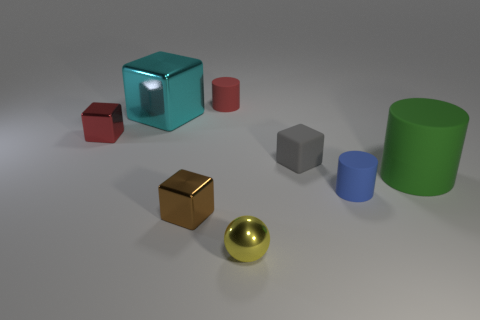What is the material of the red object that is the same shape as the small blue object?
Offer a very short reply. Rubber. There is a metallic cube in front of the tiny gray matte thing that is behind the brown shiny object; how big is it?
Make the answer very short. Small. The big metallic block is what color?
Your response must be concise. Cyan. There is a brown thing in front of the tiny red metallic block; how many cylinders are left of it?
Ensure brevity in your answer.  0. There is a tiny rubber cylinder that is on the left side of the yellow shiny object; is there a small matte cylinder in front of it?
Offer a terse response. Yes. Are there any red objects to the right of the small red metal cube?
Provide a succinct answer. Yes. There is a big object on the right side of the blue rubber cylinder; is its shape the same as the small brown object?
Make the answer very short. No. What number of rubber things are the same shape as the small brown metallic thing?
Your response must be concise. 1. Is there a blue cylinder made of the same material as the large green cylinder?
Offer a very short reply. Yes. There is a small block right of the tiny matte cylinder to the left of the gray block; what is its material?
Provide a succinct answer. Rubber. 